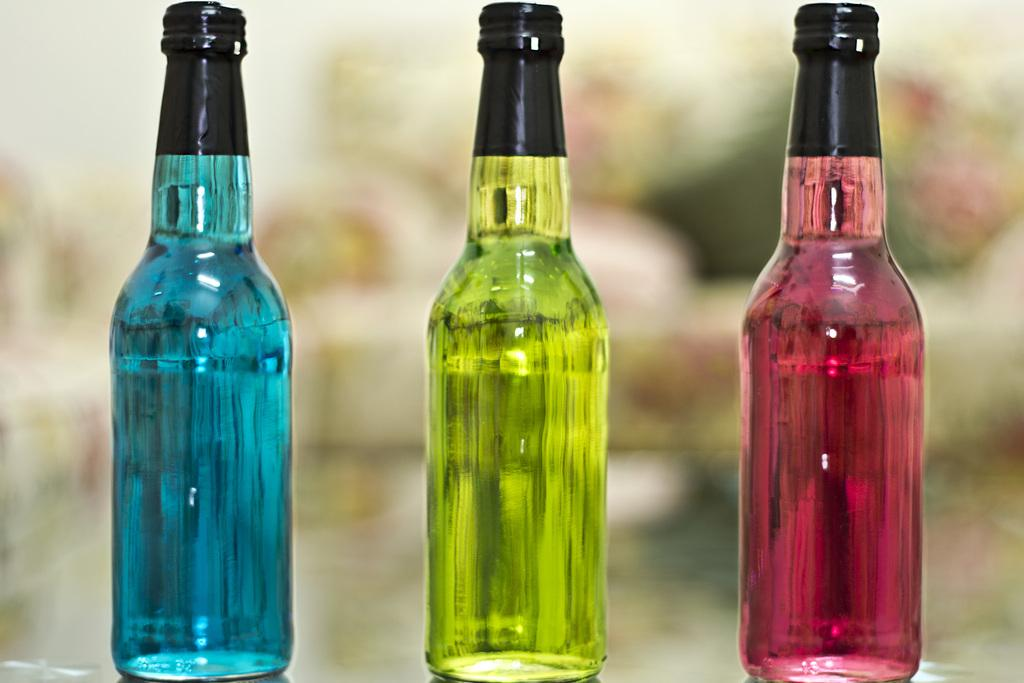How many bottles are visible in the image? There are three bottles in the image. What color are the caps on the bottles? The caps on the bottles are black. Can you describe the background of the image? The background of the image is not clear. What type of berry is growing on the wall in the image? There are no berries or walls present in the image; it only features three bottles with black caps. 